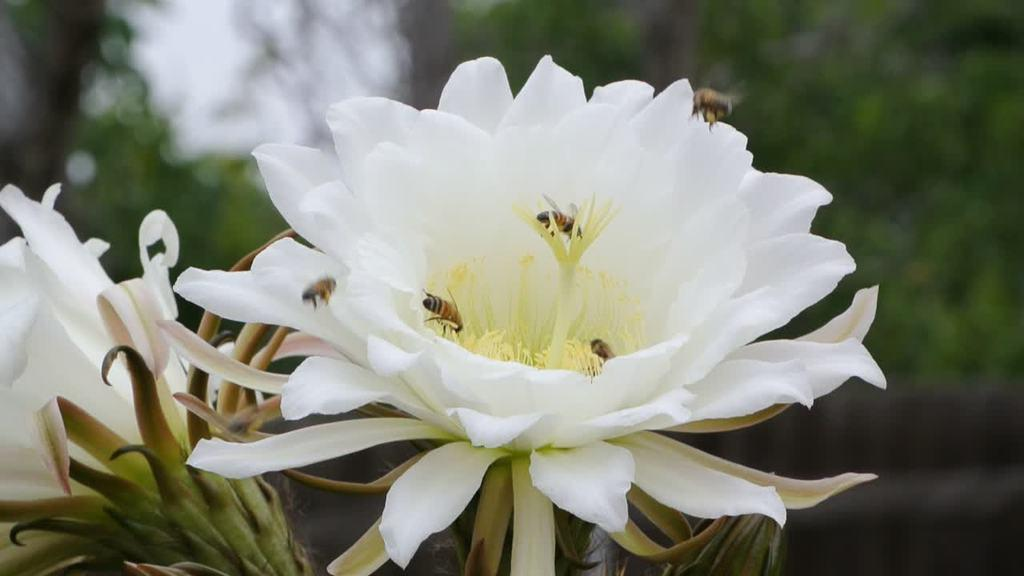What is the main subject of the image? There is a flower in the image. Are there any other living organisms present on the flower? Yes, there are insects on the flower. Can you describe the background of the image? The background of the image is blurry. What type of army is visible in the image? There is no army present in the image; it features a flower with insects and a blurry background. What appliance is being used to take the picture in the image? The image does not provide information about the camera or appliance used to take the picture. 